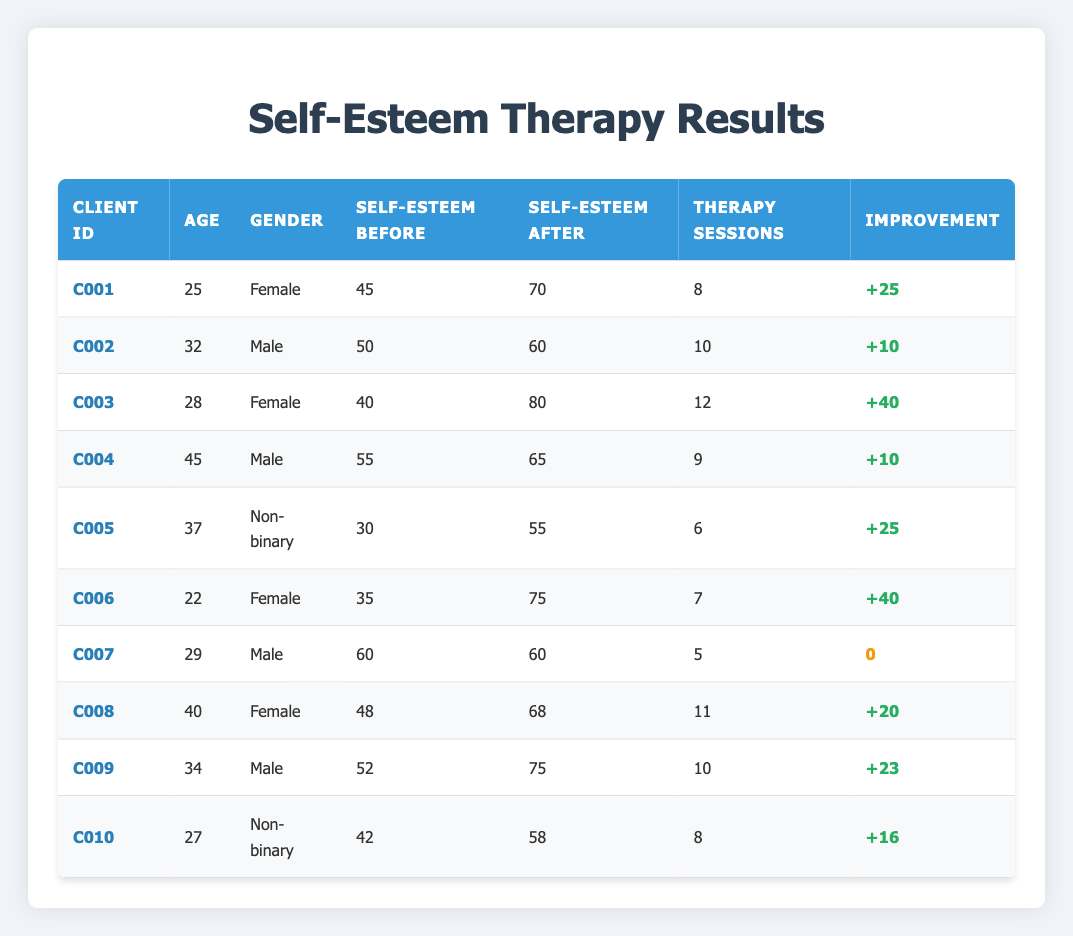What is the self-esteem score of client C001 before therapy? From the table, looking at the row for client C001, the self-esteem score before therapy is given as 45.
Answer: 45 What is the improvement in self-esteem for client C006? Looking at the row for client C006, the self-esteem score before therapy is 35 and after therapy is 75. The improvement can be calculated by subtracting the before score from the after score: 75 - 35 = 40.
Answer: 40 Did client C007 show any improvement in self-esteem? For client C007, the self-esteem score before therapy is 60 and after therapy is also 60. Therefore, there was no change in the score.
Answer: No Which client experienced the greatest improvement in self-esteem? By reviewing the table, we need to look for the maximum difference in scores. Client C003 has a before score of 40 and an after score of 80, resulting in an improvement of 40. Client C006 also has an improvement of 40, but since there are no higher values, client C003 can be considered as having the greatest improvement alongside client C006.
Answer: C003 What was the average self-esteem score after therapy sessions across all clients? First, sum up all the self-esteem after scores: 70 + 60 + 80 + 65 + 55 + 75 + 60 + 68 + 75 + 58 =  716. Then, divide by the number of clients, which is 10: 716 / 10 = 71.6.
Answer: 71.6 What percentage of clients showed an increase in self-esteem? After examining the table, 9 out of 10 clients have improvements in their self-esteem scores. The calculation is done by taking (9/10) * 100 = 90%.
Answer: 90% Is there a trend in self-esteem improvement based on gender? In total, we need to count improvements for each gender. For females: C001 (+25), C003 (+40), C006 (+40), C008 (+20). For males: C002 (+10), C004 (+10), C009 (+23). Non-binary: C005 (+25), C010 (+16). Analyzing these reveals that females had higher improvements on average compared to males, thus indicating a potential trend.
Answer: Yes Which client had the lowest self-esteem score before therapy? Looking through the table, client C005 has the lowest self-esteem score before therapy at 30.
Answer: C005 